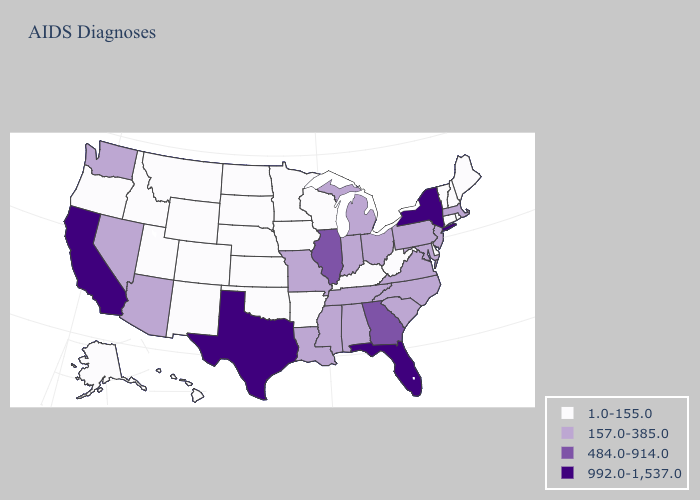Among the states that border Colorado , does Arizona have the highest value?
Write a very short answer. Yes. Name the states that have a value in the range 992.0-1,537.0?
Keep it brief. California, Florida, New York, Texas. Name the states that have a value in the range 992.0-1,537.0?
Be succinct. California, Florida, New York, Texas. What is the value of Montana?
Concise answer only. 1.0-155.0. Name the states that have a value in the range 484.0-914.0?
Keep it brief. Georgia, Illinois. Which states have the lowest value in the USA?
Write a very short answer. Alaska, Arkansas, Colorado, Connecticut, Delaware, Hawaii, Idaho, Iowa, Kansas, Kentucky, Maine, Minnesota, Montana, Nebraska, New Hampshire, New Mexico, North Dakota, Oklahoma, Oregon, Rhode Island, South Dakota, Utah, Vermont, West Virginia, Wisconsin, Wyoming. Among the states that border Ohio , does West Virginia have the lowest value?
Concise answer only. Yes. Name the states that have a value in the range 1.0-155.0?
Keep it brief. Alaska, Arkansas, Colorado, Connecticut, Delaware, Hawaii, Idaho, Iowa, Kansas, Kentucky, Maine, Minnesota, Montana, Nebraska, New Hampshire, New Mexico, North Dakota, Oklahoma, Oregon, Rhode Island, South Dakota, Utah, Vermont, West Virginia, Wisconsin, Wyoming. What is the value of Arkansas?
Write a very short answer. 1.0-155.0. What is the value of Hawaii?
Answer briefly. 1.0-155.0. Among the states that border Michigan , which have the highest value?
Write a very short answer. Indiana, Ohio. Among the states that border Pennsylvania , which have the highest value?
Be succinct. New York. Among the states that border Connecticut , which have the highest value?
Be succinct. New York. Among the states that border Maine , which have the lowest value?
Concise answer only. New Hampshire. What is the value of Oklahoma?
Answer briefly. 1.0-155.0. 